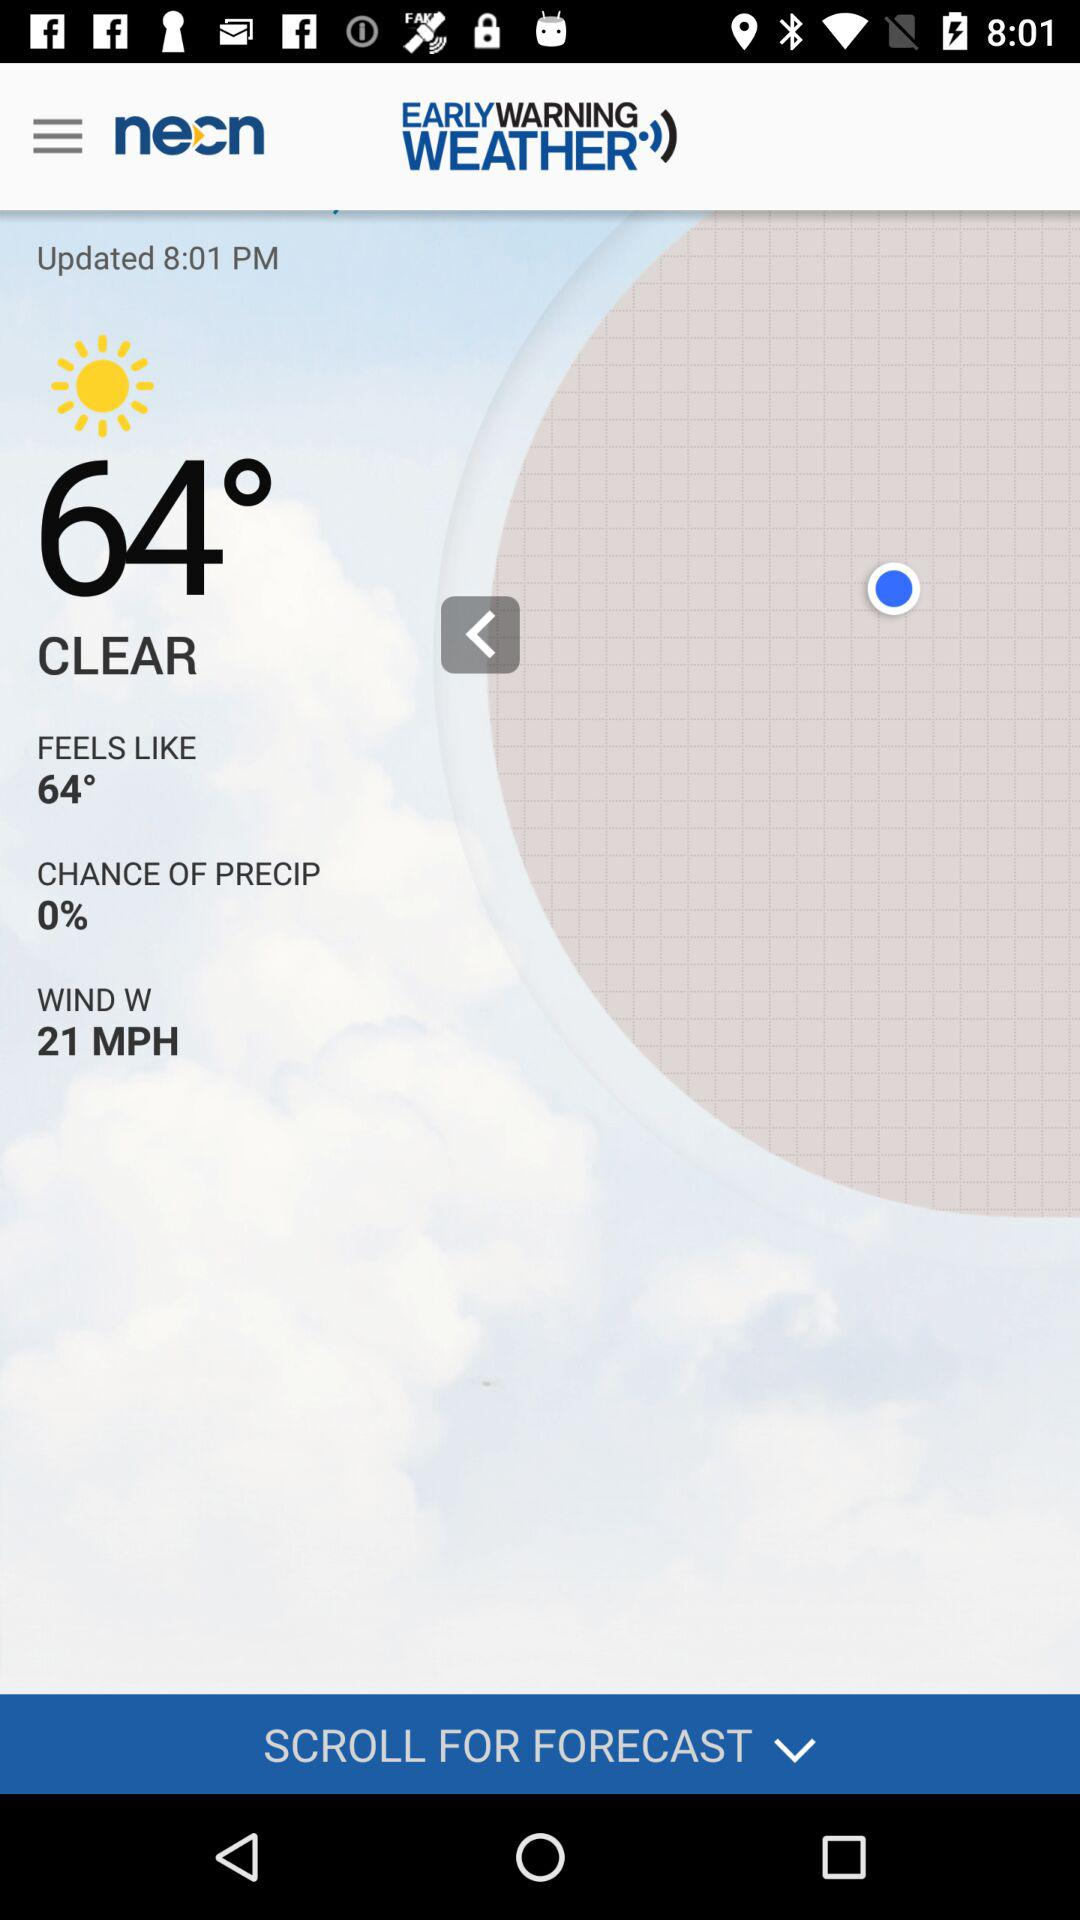What is the difference between the temperature and the feels like temperature?
Answer the question using a single word or phrase. 0° 